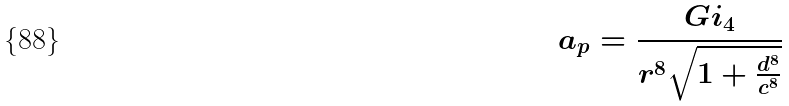<formula> <loc_0><loc_0><loc_500><loc_500>a _ { p } = \frac { G i _ { 4 } } { r ^ { 8 } \sqrt { 1 + \frac { d ^ { 8 } } { c ^ { 8 } } } }</formula> 